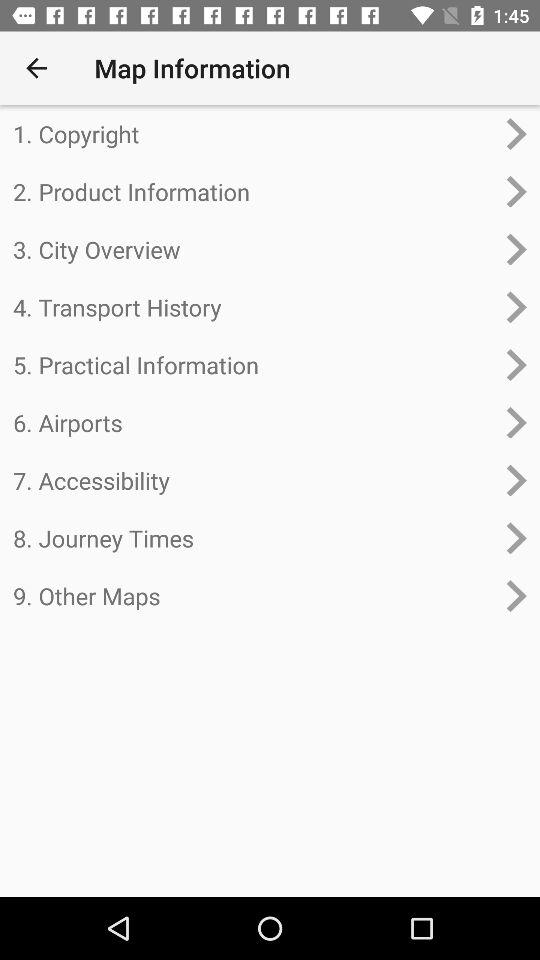What's the first option in "Map Information"? The first option is "Copyright". 